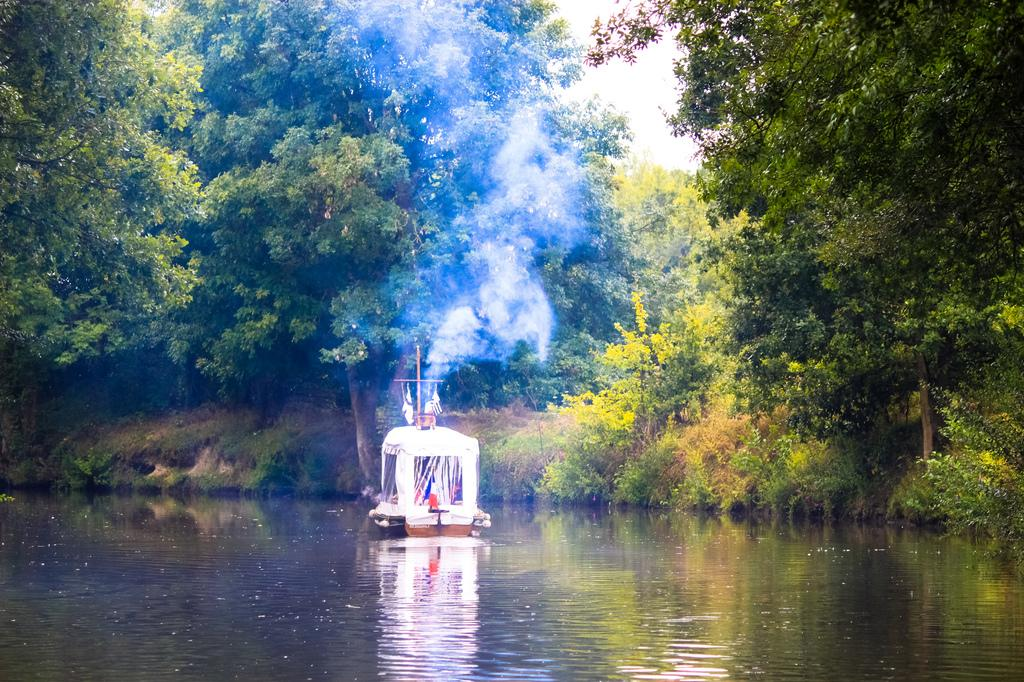What is the main subject in the foreground of the image? There is a boat in the foreground of the image. Where is the boat located? The boat is in a river. What can be seen in the background of the image? There are trees, plants, grass, and the sky visible in the background of the image. Is there any indication of human activity in the background? Yes, there is smoke in the background of the image, which may suggest human activity. What news headline is visible on the boat in the image? There is no news headline visible on the boat in the image. What historical event is depicted in the image? There is no historical event depicted in the image; it shows a boat in a river with a background of trees, plants, grass, and the sky. 